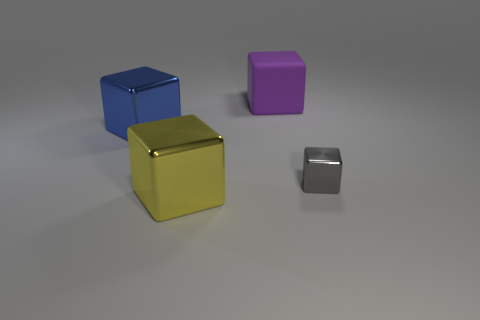Add 1 gray blocks. How many objects exist? 5 Subtract 0 brown cubes. How many objects are left? 4 Subtract all tiny brown rubber spheres. Subtract all tiny gray blocks. How many objects are left? 3 Add 3 matte objects. How many matte objects are left? 4 Add 2 large gray spheres. How many large gray spheres exist? 2 